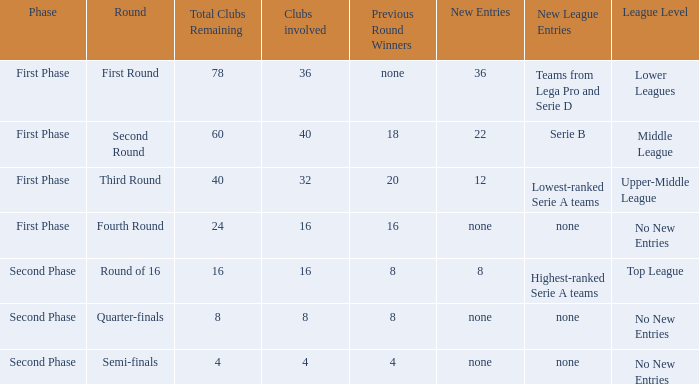During the first phase portion of phase and having 16 clubs involved; what would you find for the winners from previous round? 16.0. 